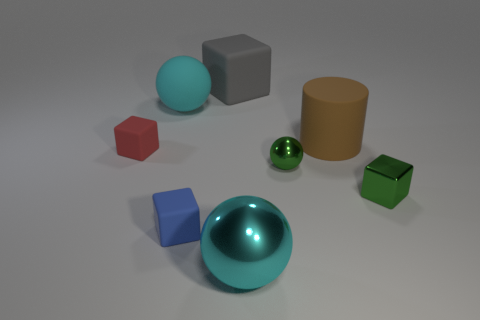What number of rubber things are either tiny blue cylinders or small red things?
Ensure brevity in your answer.  1. What is the shape of the big object that is the same color as the large rubber sphere?
Your answer should be very brief. Sphere. There is a rubber block in front of the tiny red matte object; is its color the same as the cylinder?
Your answer should be very brief. No. What shape is the green object on the right side of the large object on the right side of the big cyan metal object?
Ensure brevity in your answer.  Cube. What number of objects are cubes behind the green block or metallic objects in front of the tiny metallic cube?
Provide a succinct answer. 3. There is a cyan object that is the same material as the cylinder; what shape is it?
Offer a very short reply. Sphere. Is there any other thing that is the same color as the large metal ball?
Provide a short and direct response. Yes. Are there an equal number of big blue shiny objects and big cyan things?
Offer a terse response. No. There is a green object that is the same shape as the large gray rubber object; what is it made of?
Your answer should be very brief. Metal. How many other things are there of the same size as the metallic cube?
Keep it short and to the point. 3. 